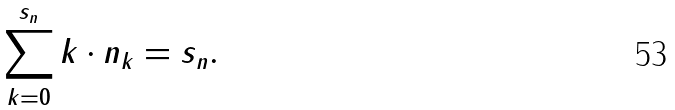<formula> <loc_0><loc_0><loc_500><loc_500>\sum ^ { s _ { n } } _ { k = 0 } k \cdot n _ { k } = s _ { n } .</formula> 